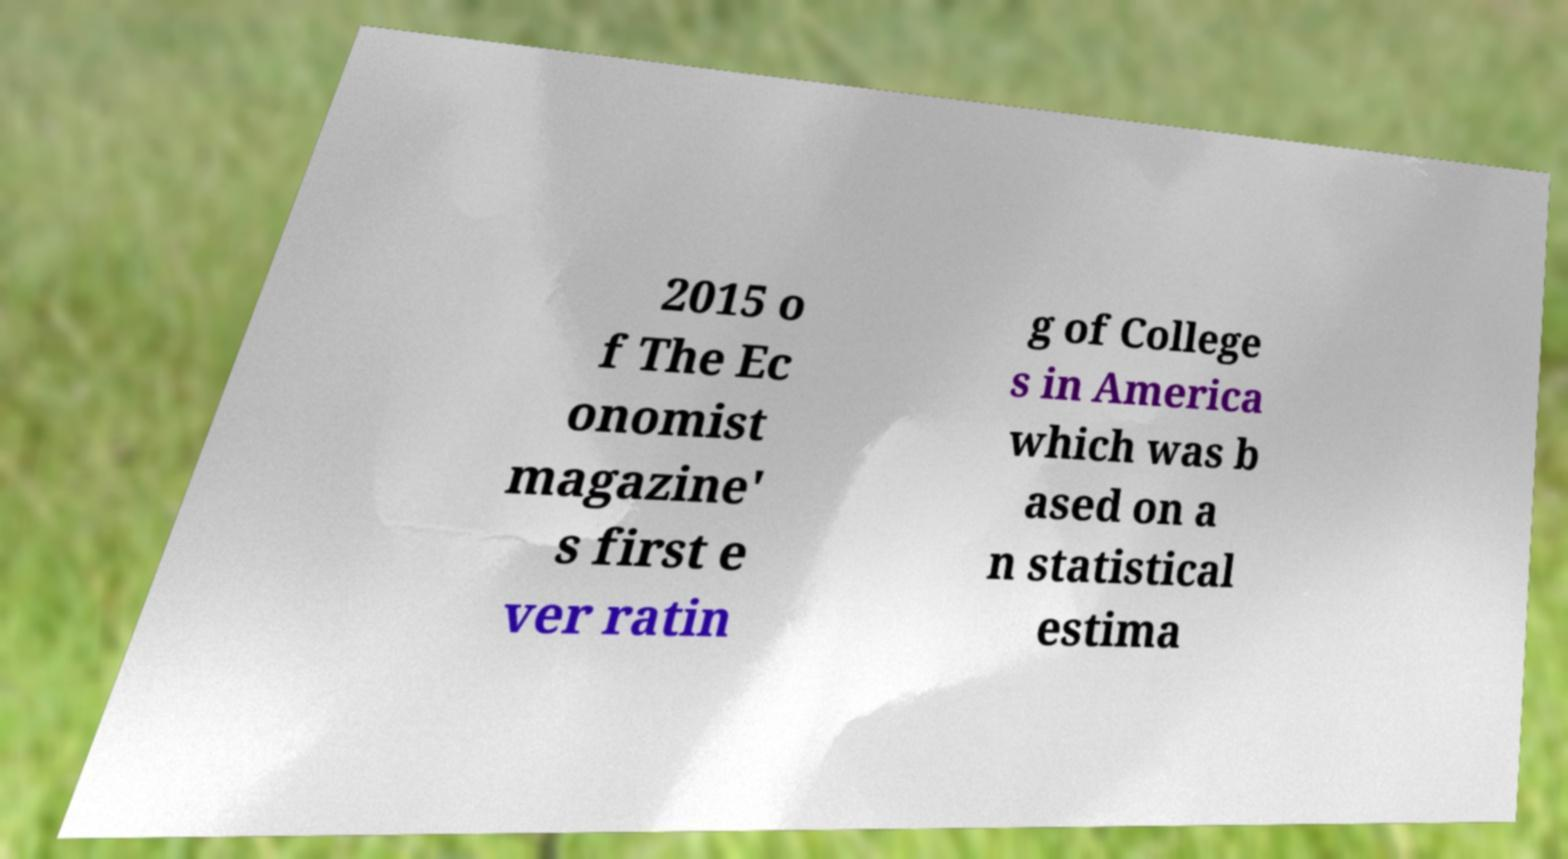There's text embedded in this image that I need extracted. Can you transcribe it verbatim? 2015 o f The Ec onomist magazine' s first e ver ratin g of College s in America which was b ased on a n statistical estima 